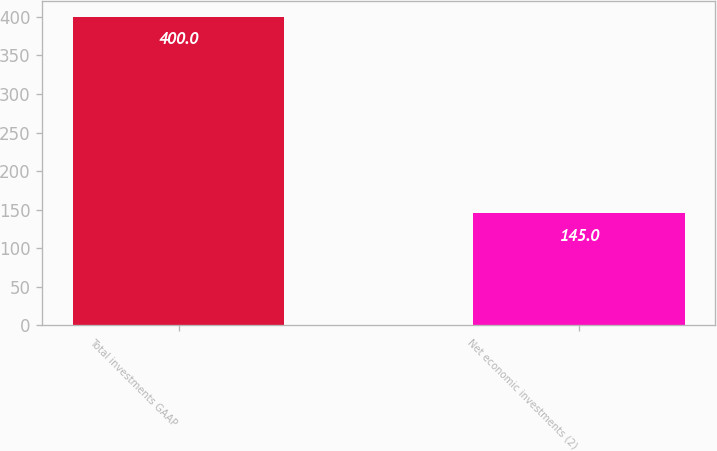Convert chart. <chart><loc_0><loc_0><loc_500><loc_500><bar_chart><fcel>Total investments GAAP<fcel>Net economic investments (2)<nl><fcel>400<fcel>145<nl></chart> 